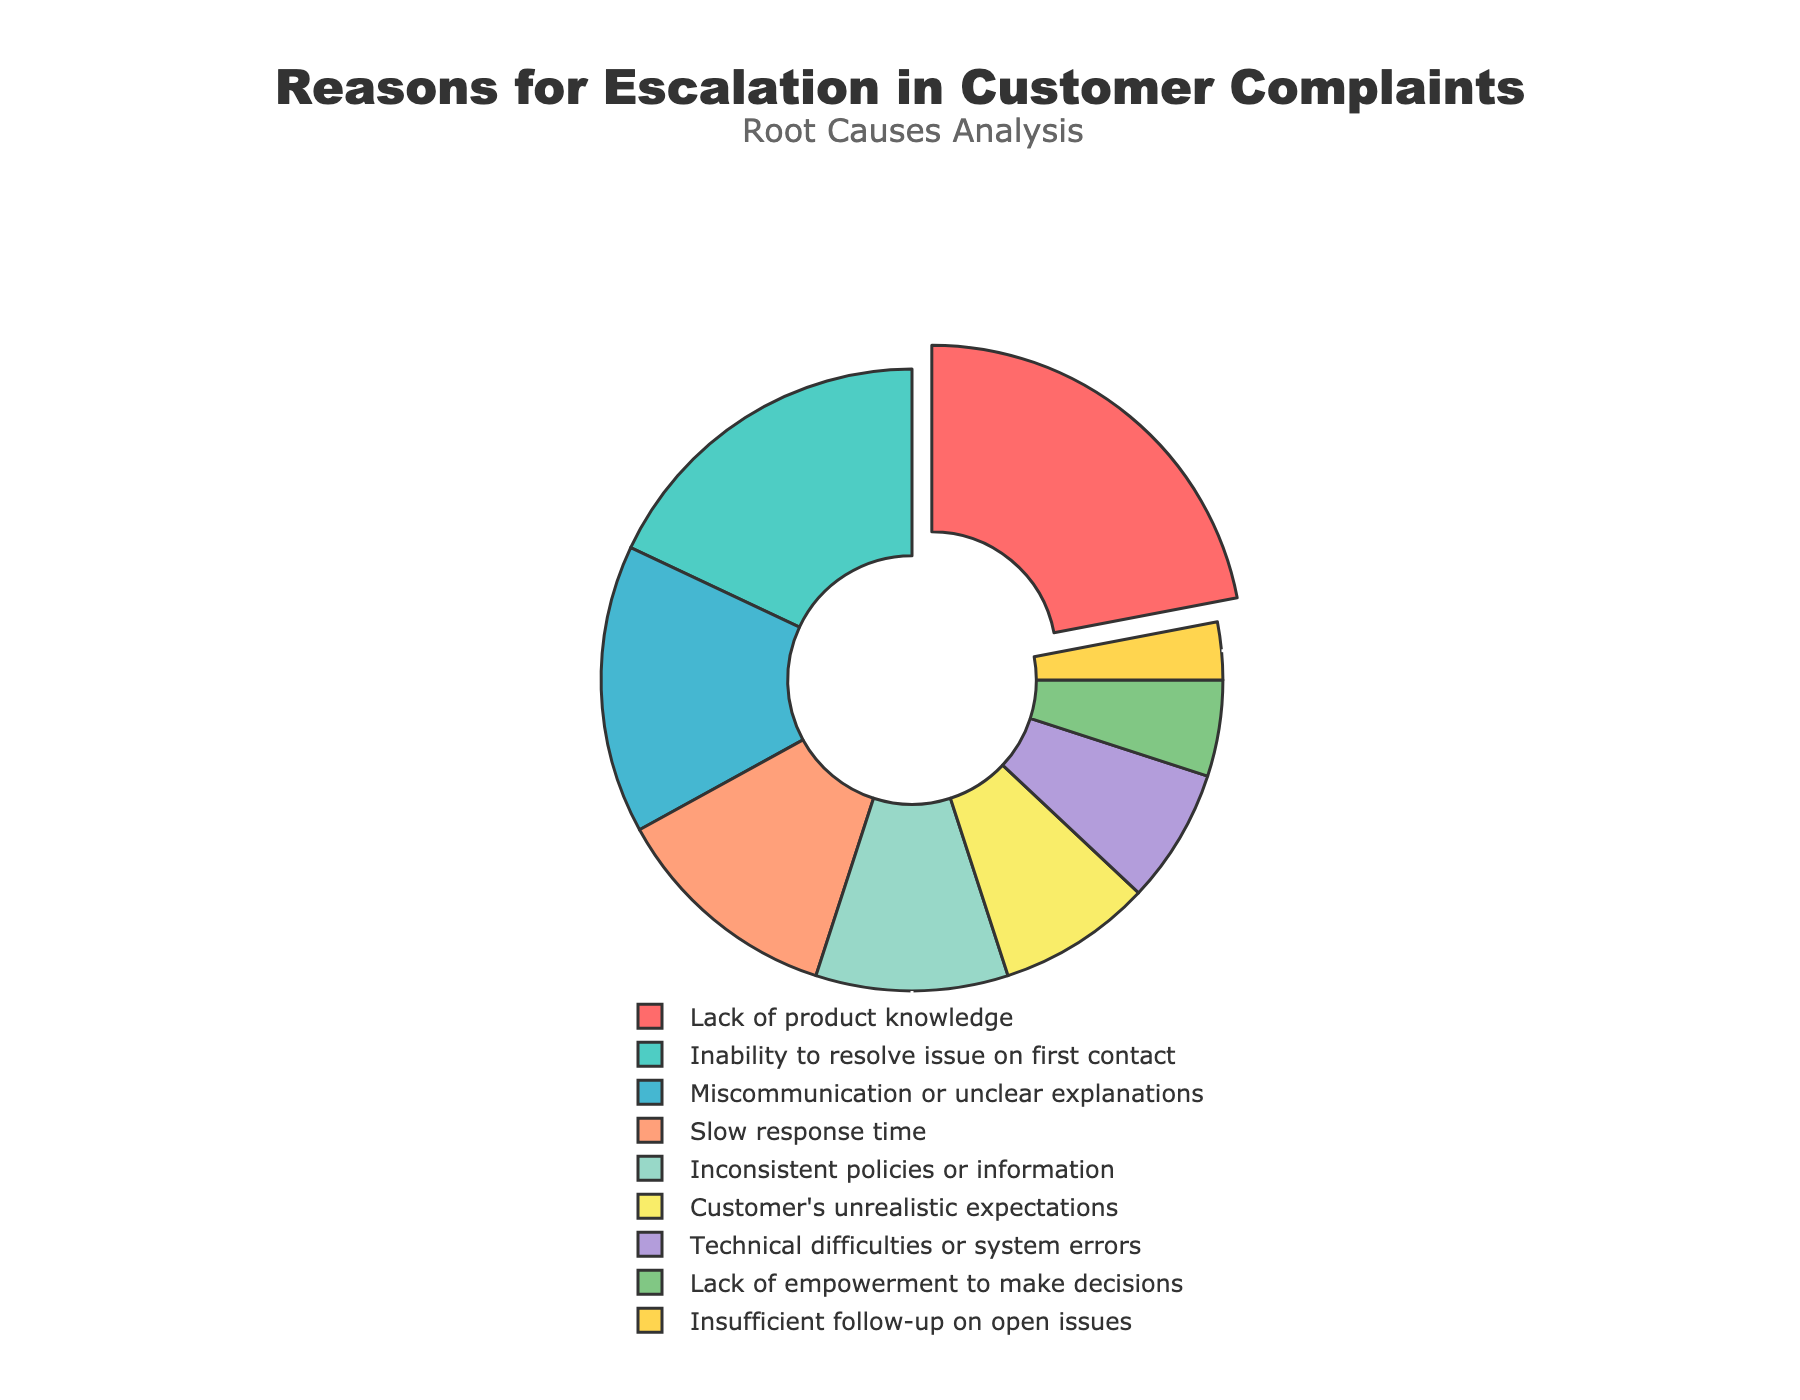what is the most common reason for escalation in customer complaints? The figure shows that "Lack of product knowledge" has the highest percentage.
Answer: Lack of product knowledge which issue has a larger percentage: Miscommunication or unclear explanations, or slow response time? The figure shows "Miscommunication or unclear explanations" at 15%, which is higher than "Slow response time" at 12%.
Answer: Miscommunication or unclear explanations what is the total percentage of issues related to "Lack of product knowledge" and "Inability to resolve issue on first contact"? Add the percentages of both categories. "Lack of product knowledge" is 22% and "Inability to resolve issue on first contact" is 18%. Sum: 22 + 18 = 40%.
Answer: 40% how many categories have a percentage below 10%? The figure shows four categories below 10%: "Customer's unrealistic expectations" (8%), "Technical difficulties or system errors" (7%), "Lack of empowerment to make decisions" (5%), and "Insufficient follow-up on open issues" (3%).
Answer: four what is the difference in percentage between the category with the highest percentage and the category with the lowest percentage? The highest percentage is "Lack of product knowledge" at 22%, and the lowest is "Insufficient follow-up on open issues" at 3%. Difference: 22 - 3 = 19%.
Answer: 19% which category is represented by the color red? By referring to the colors, the red section represents "Lack of product knowledge."
Answer: Lack of product knowledge which has a higher percentage: Inconsistent policies or information, or Technical difficulties or system errors? "Inconsistent policies or information" has a higher percentage (10%) compared to "Technical difficulties or system errors" (7%).
Answer: Inconsistent policies or information what can you infer about the empowerment to make decisions from the chart? "Lack of empowerment to make decisions" has a relatively low percentage of 5%, suggesting it is not a major cause of escalation in complaints compared to other issues.
Answer: It is not a major cause compare the percentage of "Slow response time" with the combined percentages of "Customer's unrealistic expectations" and "Technical difficulties or system errors". Which is higher? "Slow response time" is 12%. Combine "Customer's unrealistic expectations" (8%) and "Technical difficulties or system errors" (7%). Sum: 8 + 7 = 15%, which is higher than 12%.
Answer: The combined percentages Is "Inability to resolve issue on first contact" more common than "Inconsistent policies or information"? Yes, "Inability to resolve issue on first contact" has a higher percentage (18%) compared to "Inconsistent policies or information" (10%).
Answer: Yes 